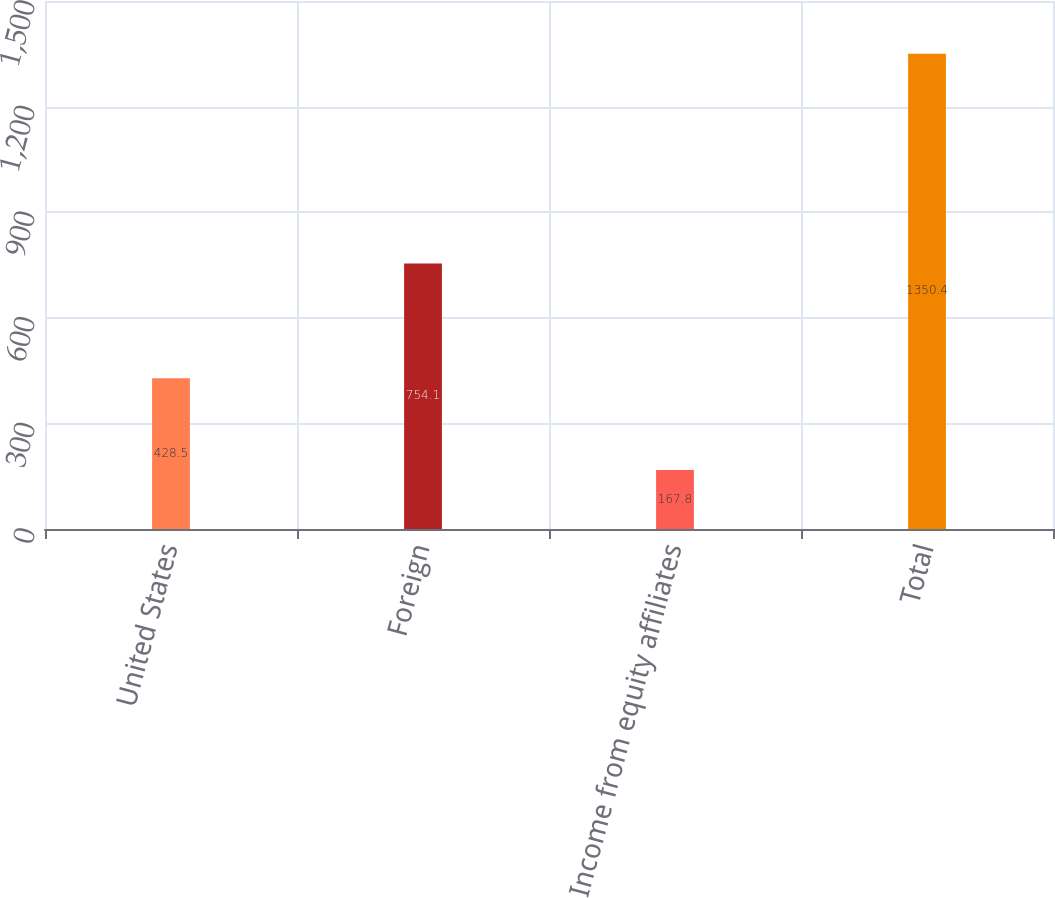Convert chart. <chart><loc_0><loc_0><loc_500><loc_500><bar_chart><fcel>United States<fcel>Foreign<fcel>Income from equity affiliates<fcel>Total<nl><fcel>428.5<fcel>754.1<fcel>167.8<fcel>1350.4<nl></chart> 